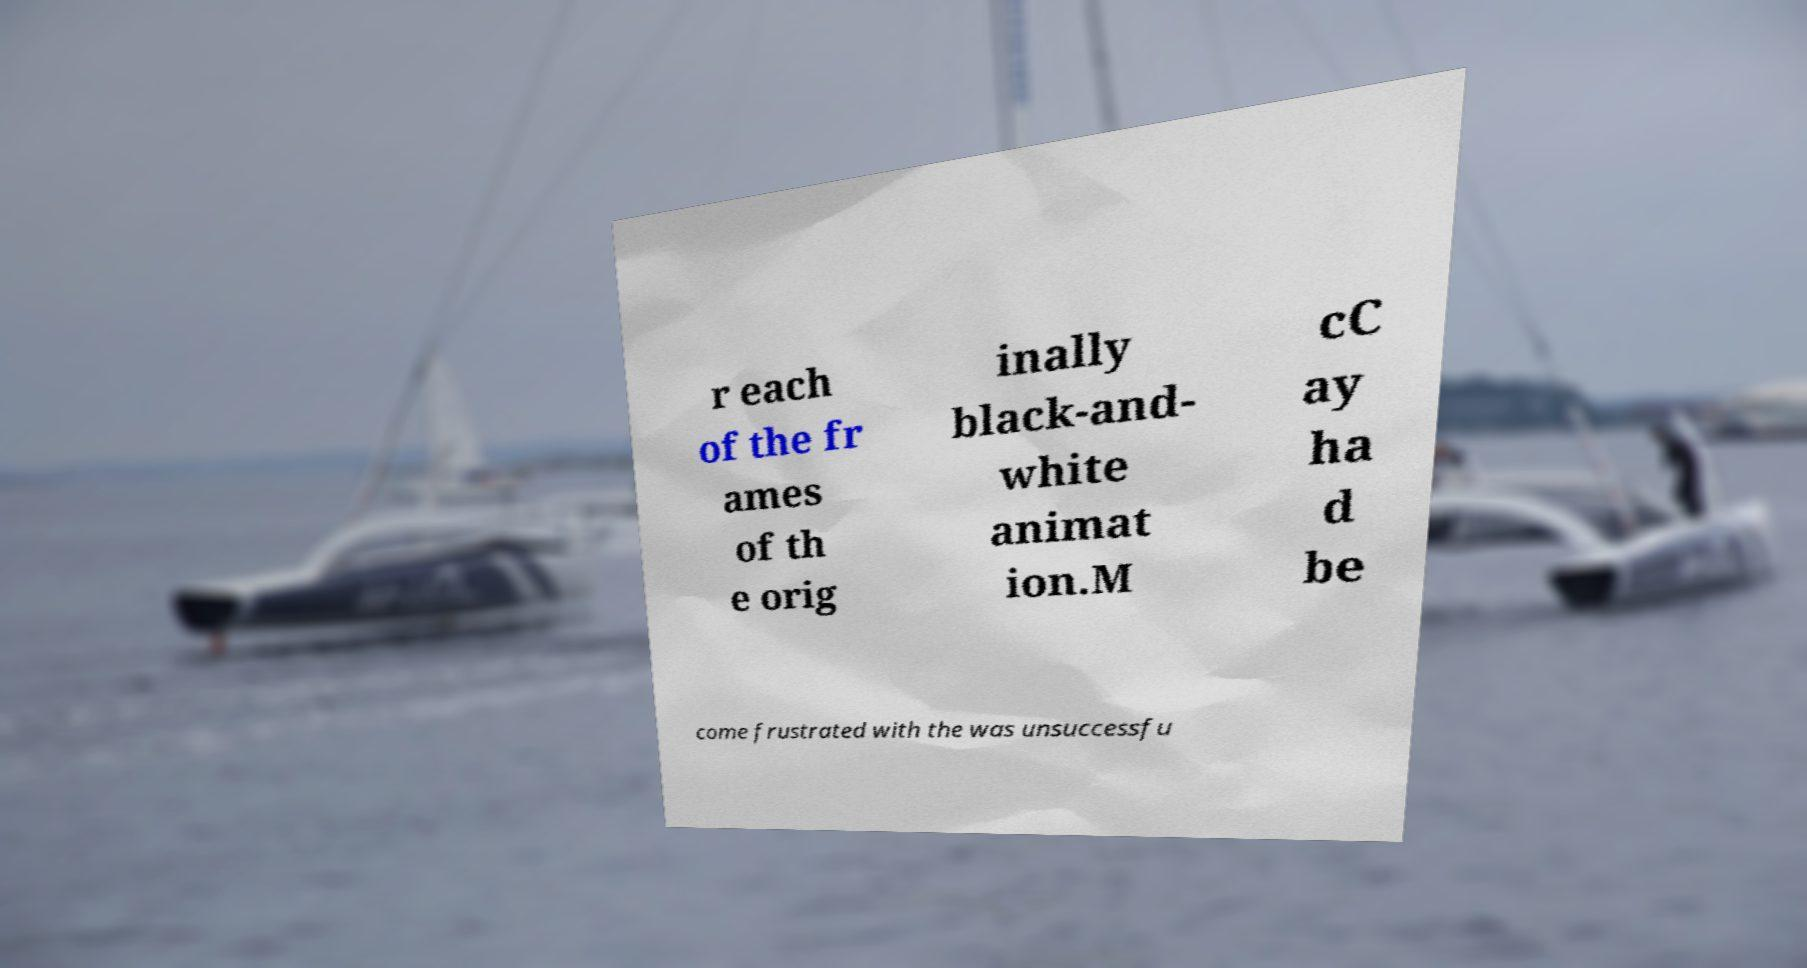Can you accurately transcribe the text from the provided image for me? r each of the fr ames of th e orig inally black-and- white animat ion.M cC ay ha d be come frustrated with the was unsuccessfu 